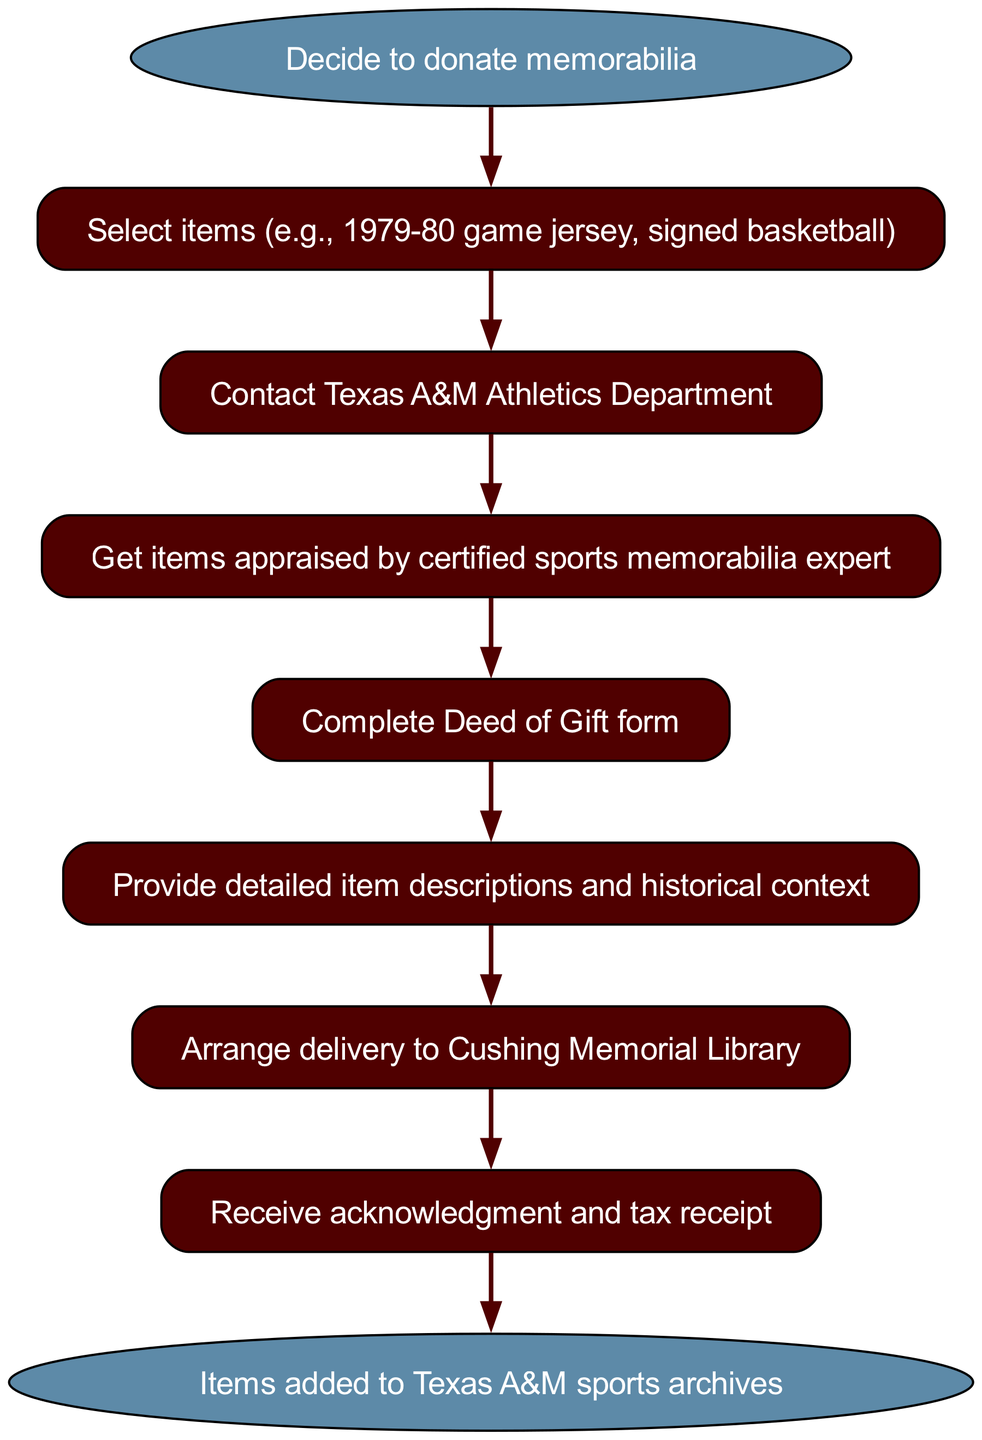What is the first step in the donation process? The diagram begins with the "Decide to donate memorabilia" step, which is the starting point of the process.
Answer: Decide to donate memorabilia How many nodes are present in the diagram? The diagram includes eight nodes: one start node, one end node, and six other process steps in between.
Answer: Eight What step comes after selecting items? Following the "Select items (e.g., 1979-80 game jersey, signed basketball)" node, the next step is to "Contact Texas A&M Athletics Department".
Answer: Contact Texas A&M Athletics Department What is required before filling out the Deed of Gift form? The process indicates that one must "Get items appraised by certified sports memorabilia expert" before completing the Deed of Gift form.
Answer: Get items appraised by certified sports memorabilia expert Which two steps are directly connected to the receipt? The "Receive acknowledgment and tax receipt" node is directly preceded by the "Arrange delivery to Cushing Memorial Library" node and directly connected to the "Items added to Texas A&M sports archives" node.
Answer: Arrange delivery to Cushing Memorial Library What kind of items should be selected for donation? The flow chart example suggests selecting items like a "1979-80 game jersey" and a "signed basketball", both significant to Texas A&M sports history.
Answer: 1979-80 game jersey, signed basketball How many steps are there between the choice to donate and the items being added to the archives? The process entails a total of seven steps, moving from the initial decision to the final addition of items to the archives.
Answer: Seven What happens after the item descriptions are provided? The next action in the process is to "Arrange delivery to Cushing Memorial Library" following the detailed descriptions and historical context of the items.
Answer: Arrange delivery to Cushing Memorial Library 